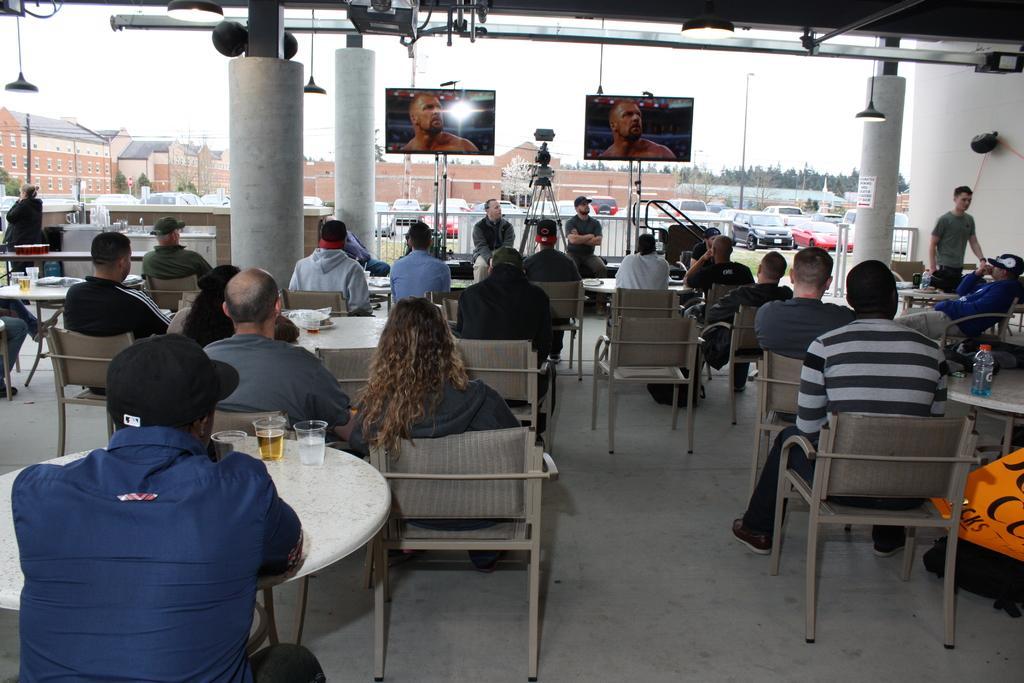Could you give a brief overview of what you see in this image? On the background we can see sky, buildings and trees and few vehicles parked over there. Here we can see all the persons sittimng on chairs infront of a table on the table we can see bottle and drinking glasses with a drink. We can see two men sitting here. These are two televisions. This is a pillar, lights. 